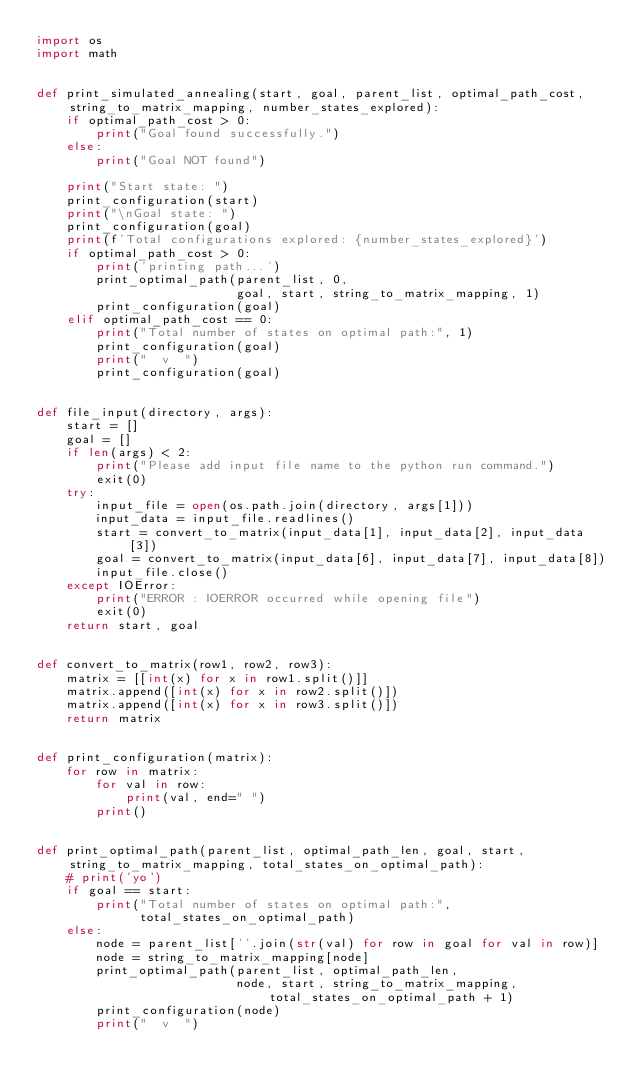Convert code to text. <code><loc_0><loc_0><loc_500><loc_500><_Python_>import os
import math


def print_simulated_annealing(start, goal, parent_list, optimal_path_cost, string_to_matrix_mapping, number_states_explored):
    if optimal_path_cost > 0:
        print("Goal found successfully.")
    else:
        print("Goal NOT found")

    print("Start state: ")
    print_configuration(start)
    print("\nGoal state: ")
    print_configuration(goal)
    print(f'Total configurations explored: {number_states_explored}')
    if optimal_path_cost > 0:
        print('printing path...')
        print_optimal_path(parent_list, 0,
                           goal, start, string_to_matrix_mapping, 1)
        print_configuration(goal)
    elif optimal_path_cost == 0:
        print("Total number of states on optimal path:", 1)
        print_configuration(goal)
        print("  v  ")
        print_configuration(goal)


def file_input(directory, args):
    start = []
    goal = []
    if len(args) < 2:
        print("Please add input file name to the python run command.")
        exit(0)
    try:
        input_file = open(os.path.join(directory, args[1]))
        input_data = input_file.readlines()
        start = convert_to_matrix(input_data[1], input_data[2], input_data[3])
        goal = convert_to_matrix(input_data[6], input_data[7], input_data[8])
        input_file.close()
    except IOError:
        print("ERROR : IOERROR occurred while opening file")
        exit(0)
    return start, goal


def convert_to_matrix(row1, row2, row3):
    matrix = [[int(x) for x in row1.split()]]
    matrix.append([int(x) for x in row2.split()])
    matrix.append([int(x) for x in row3.split()])
    return matrix


def print_configuration(matrix):
    for row in matrix:
        for val in row:
            print(val, end=" ")
        print()


def print_optimal_path(parent_list, optimal_path_len, goal, start, string_to_matrix_mapping, total_states_on_optimal_path):
    # print('yo')
    if goal == start:
        print("Total number of states on optimal path:",
              total_states_on_optimal_path)
    else:
        node = parent_list[''.join(str(val) for row in goal for val in row)]
        node = string_to_matrix_mapping[node]
        print_optimal_path(parent_list, optimal_path_len,
                           node, start, string_to_matrix_mapping, total_states_on_optimal_path + 1)
        print_configuration(node)
        print("  v  ")
</code> 